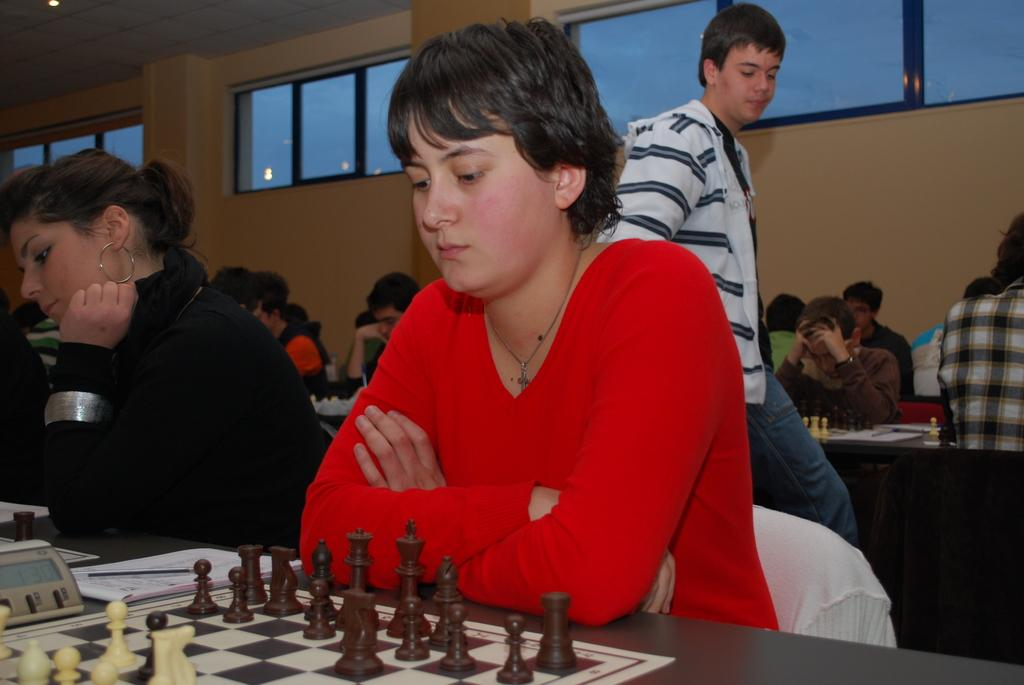What activity are the persons in the image engaged in? The group of persons in the image are playing chess. Can you describe the attire of one of the persons in the image? There is a person wearing a red color dress in the image. Is the person wearing red also participating in the game? Yes, the person wearing red is also playing chess. What type of cloud can be seen in the image? There are no clouds present in the image; it features a group of persons playing chess. How many ants are visible on the chessboard in the image? There are no ants visible on the chessboard in the image; it only shows the chess pieces and the persons playing the game. 